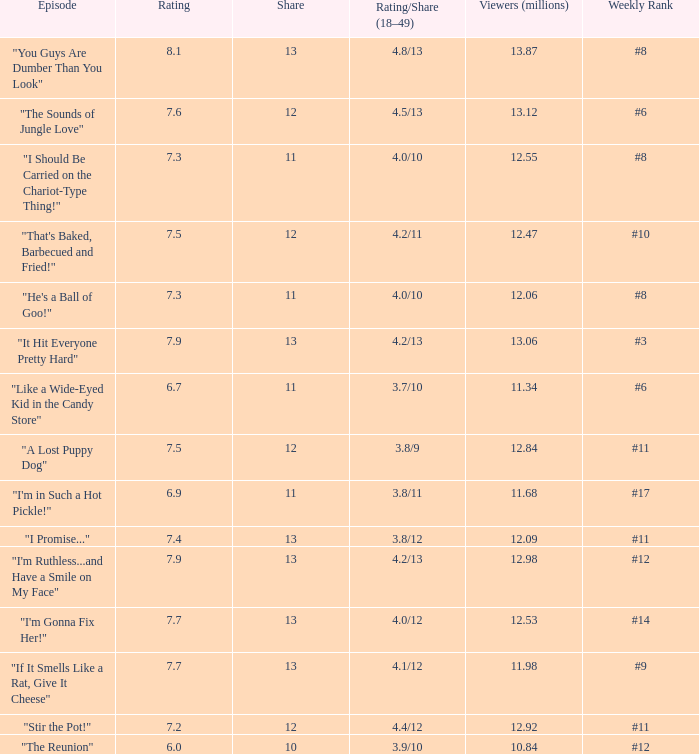What is the average rating for "a lost puppy dog"? 7.5. 